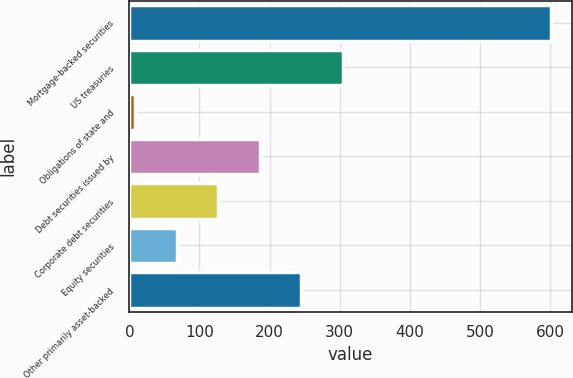Convert chart. <chart><loc_0><loc_0><loc_500><loc_500><bar_chart><fcel>Mortgage-backed securities<fcel>US treasuries<fcel>Obligations of state and<fcel>Debt securities issued by<fcel>Corporate debt securities<fcel>Equity securities<fcel>Other primarily asset-backed<nl><fcel>601<fcel>304.5<fcel>8<fcel>185.9<fcel>126.6<fcel>67.3<fcel>245.2<nl></chart> 